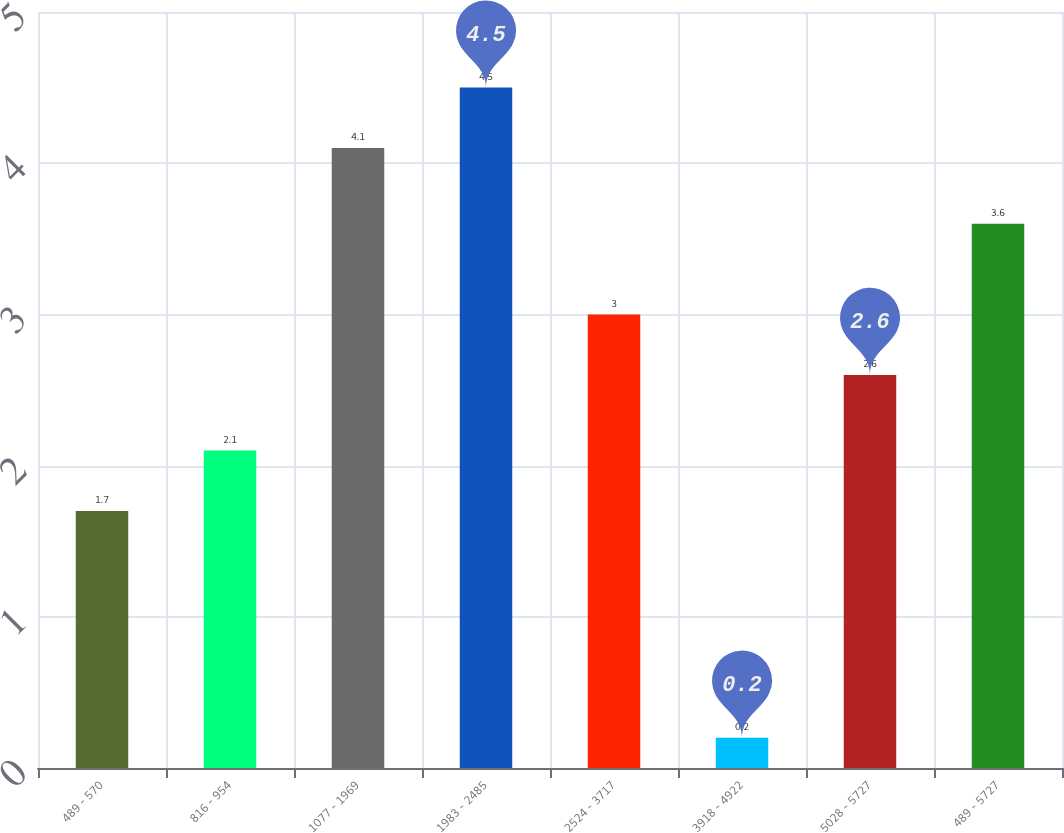Convert chart to OTSL. <chart><loc_0><loc_0><loc_500><loc_500><bar_chart><fcel>489 - 570<fcel>816 - 954<fcel>1077 - 1969<fcel>1983 - 2485<fcel>2524 - 3717<fcel>3918 - 4922<fcel>5028 - 5727<fcel>489 - 5727<nl><fcel>1.7<fcel>2.1<fcel>4.1<fcel>4.5<fcel>3<fcel>0.2<fcel>2.6<fcel>3.6<nl></chart> 